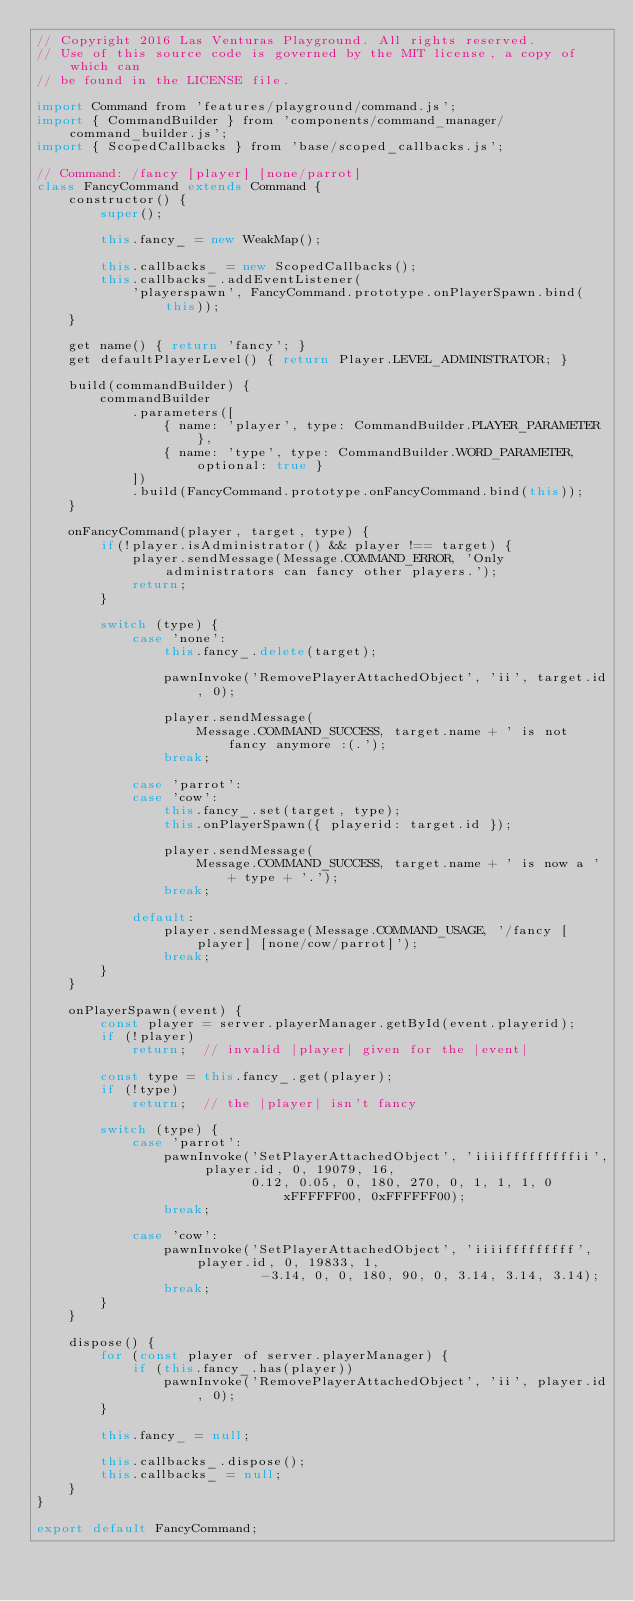<code> <loc_0><loc_0><loc_500><loc_500><_JavaScript_>// Copyright 2016 Las Venturas Playground. All rights reserved.
// Use of this source code is governed by the MIT license, a copy of which can
// be found in the LICENSE file.

import Command from 'features/playground/command.js';
import { CommandBuilder } from 'components/command_manager/command_builder.js';
import { ScopedCallbacks } from 'base/scoped_callbacks.js';

// Command: /fancy [player] [none/parrot]
class FancyCommand extends Command {
    constructor() {
        super();

        this.fancy_ = new WeakMap();

        this.callbacks_ = new ScopedCallbacks();
        this.callbacks_.addEventListener(
            'playerspawn', FancyCommand.prototype.onPlayerSpawn.bind(this));
    }

    get name() { return 'fancy'; }
    get defaultPlayerLevel() { return Player.LEVEL_ADMINISTRATOR; }

    build(commandBuilder) {
        commandBuilder
            .parameters([
                { name: 'player', type: CommandBuilder.PLAYER_PARAMETER },
                { name: 'type', type: CommandBuilder.WORD_PARAMETER, optional: true }
            ])
            .build(FancyCommand.prototype.onFancyCommand.bind(this));
    }

    onFancyCommand(player, target, type) {
        if(!player.isAdministrator() && player !== target) {
            player.sendMessage(Message.COMMAND_ERROR, 'Only administrators can fancy other players.');
            return;
        }

        switch (type) {
            case 'none':
                this.fancy_.delete(target);

                pawnInvoke('RemovePlayerAttachedObject', 'ii', target.id, 0);

                player.sendMessage(
                    Message.COMMAND_SUCCESS, target.name + ' is not fancy anymore :(.');
                break;

            case 'parrot':
            case 'cow':
                this.fancy_.set(target, type);
                this.onPlayerSpawn({ playerid: target.id });

                player.sendMessage(
                    Message.COMMAND_SUCCESS, target.name + ' is now a ' + type + '.');
                break;

            default:
                player.sendMessage(Message.COMMAND_USAGE, '/fancy [player] [none/cow/parrot]');
                break;
        }
    }

    onPlayerSpawn(event) {
        const player = server.playerManager.getById(event.playerid);
        if (!player)
            return;  // invalid |player| given for the |event|

        const type = this.fancy_.get(player);
        if (!type)
            return;  // the |player| isn't fancy

        switch (type) {
            case 'parrot':
                pawnInvoke('SetPlayerAttachedObject', 'iiiifffffffffii', player.id, 0, 19079, 16,
                           0.12, 0.05, 0, 180, 270, 0, 1, 1, 1, 0xFFFFFF00, 0xFFFFFF00);
                break;

            case 'cow':
                pawnInvoke('SetPlayerAttachedObject', 'iiiifffffffff',  player.id, 0, 19833, 1, 
                            -3.14, 0, 0, 180, 90, 0, 3.14, 3.14, 3.14);
                break;
        }
    }

    dispose() {
        for (const player of server.playerManager) {
            if (this.fancy_.has(player))
                pawnInvoke('RemovePlayerAttachedObject', 'ii', player.id, 0);
        }

        this.fancy_ = null;

        this.callbacks_.dispose();
        this.callbacks_ = null;
    }
}

export default FancyCommand;
</code> 